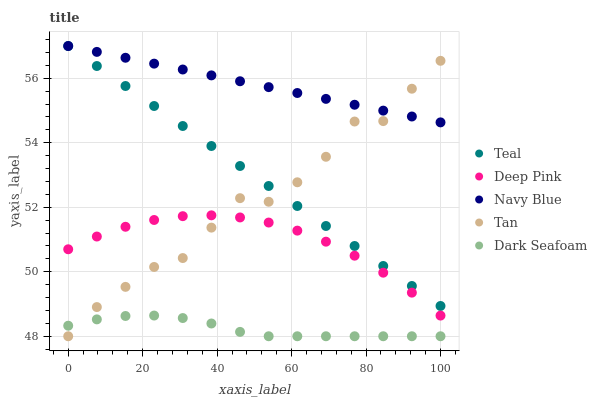Does Dark Seafoam have the minimum area under the curve?
Answer yes or no. Yes. Does Navy Blue have the maximum area under the curve?
Answer yes or no. Yes. Does Tan have the minimum area under the curve?
Answer yes or no. No. Does Tan have the maximum area under the curve?
Answer yes or no. No. Is Teal the smoothest?
Answer yes or no. Yes. Is Tan the roughest?
Answer yes or no. Yes. Is Deep Pink the smoothest?
Answer yes or no. No. Is Deep Pink the roughest?
Answer yes or no. No. Does Tan have the lowest value?
Answer yes or no. Yes. Does Deep Pink have the lowest value?
Answer yes or no. No. Does Teal have the highest value?
Answer yes or no. Yes. Does Tan have the highest value?
Answer yes or no. No. Is Deep Pink less than Navy Blue?
Answer yes or no. Yes. Is Navy Blue greater than Deep Pink?
Answer yes or no. Yes. Does Deep Pink intersect Tan?
Answer yes or no. Yes. Is Deep Pink less than Tan?
Answer yes or no. No. Is Deep Pink greater than Tan?
Answer yes or no. No. Does Deep Pink intersect Navy Blue?
Answer yes or no. No. 